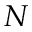<formula> <loc_0><loc_0><loc_500><loc_500>N</formula> 